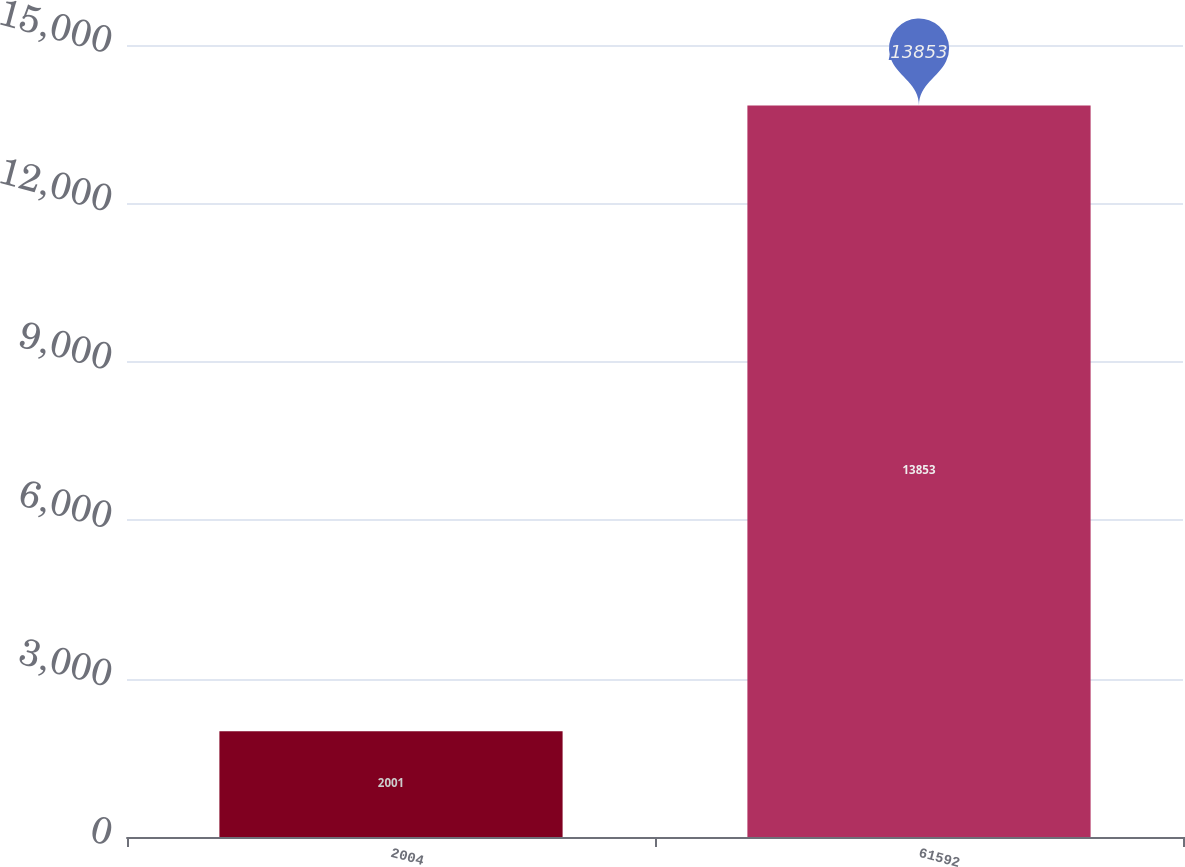<chart> <loc_0><loc_0><loc_500><loc_500><bar_chart><fcel>2004<fcel>61592<nl><fcel>2001<fcel>13853<nl></chart> 